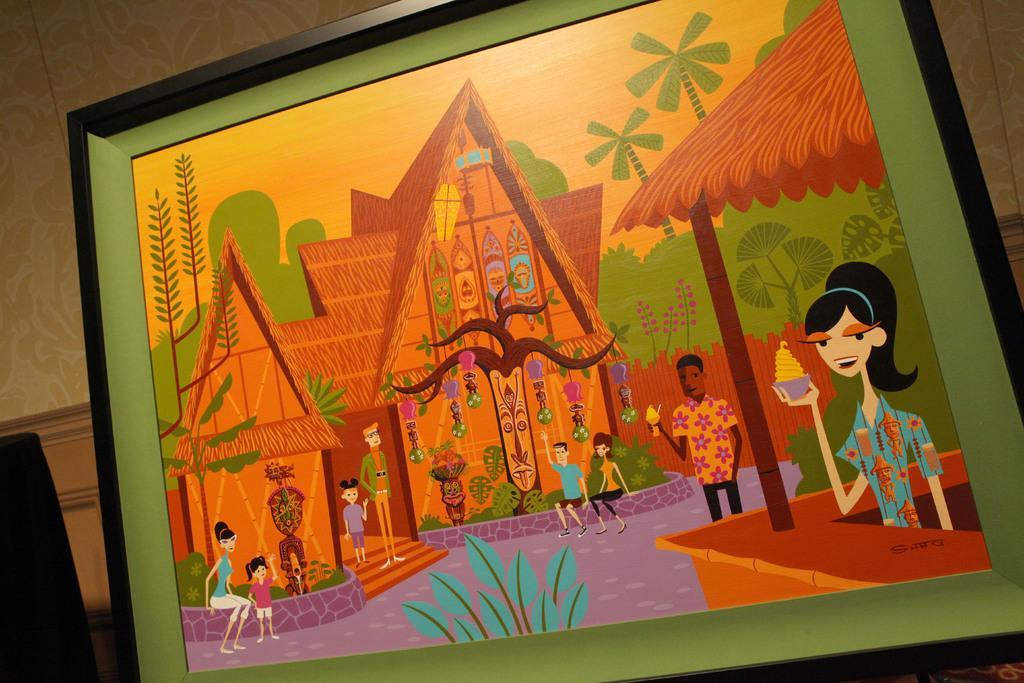Describe this image in one or two sentences. We can see frame,on this frame we can see painting of people and leaves,behind this frame we can see wall. 